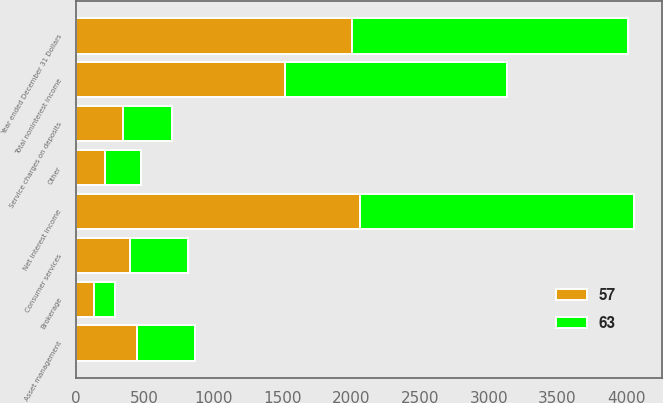Convert chart to OTSL. <chart><loc_0><loc_0><loc_500><loc_500><stacked_bar_chart><ecel><fcel>Year ended December 31 Dollars<fcel>Net interest income<fcel>Asset management<fcel>Service charges on deposits<fcel>Brokerage<fcel>Consumer services<fcel>Other<fcel>Total noninterest income<nl><fcel>63<fcel>2008<fcel>1992<fcel>420<fcel>362<fcel>153<fcel>419<fcel>262<fcel>1616<nl><fcel>57<fcel>2007<fcel>2062<fcel>445<fcel>339<fcel>134<fcel>392<fcel>208<fcel>1518<nl></chart> 